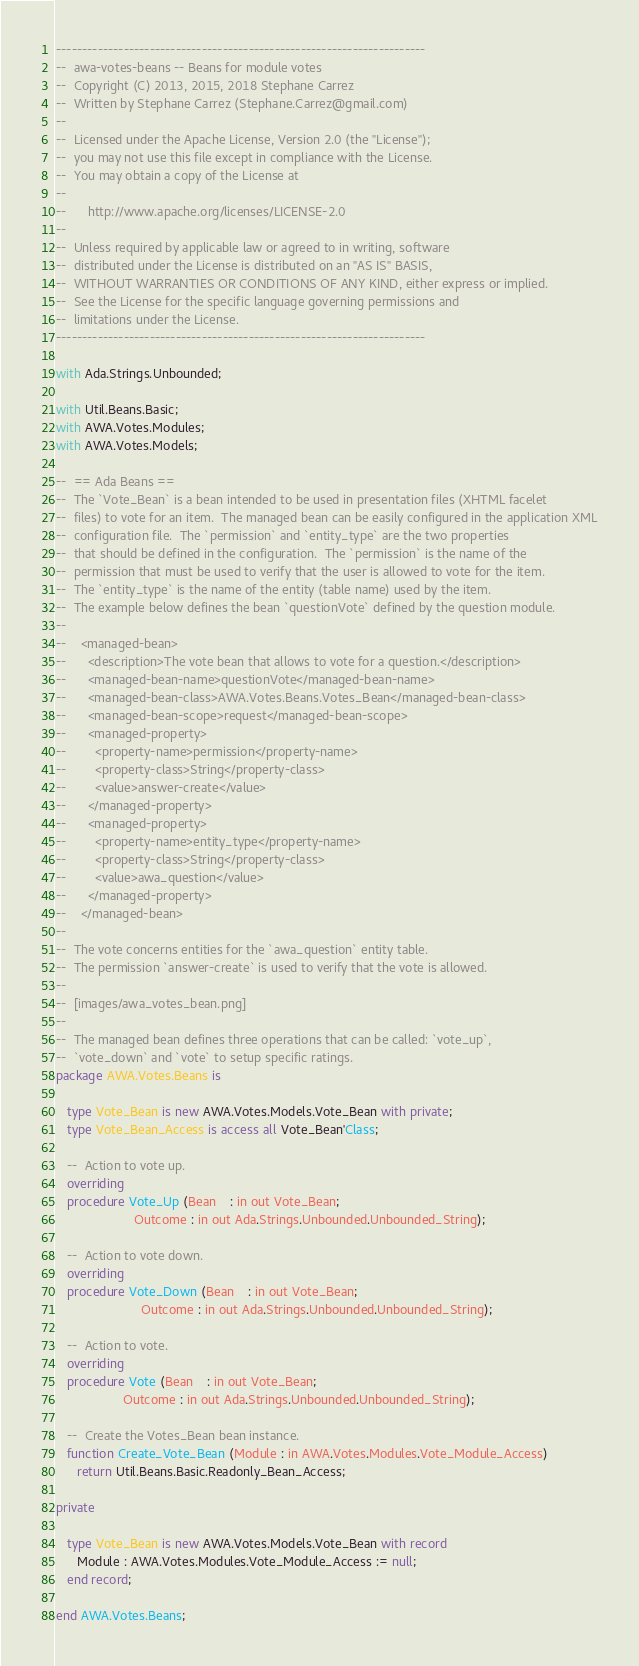<code> <loc_0><loc_0><loc_500><loc_500><_Ada_>-----------------------------------------------------------------------
--  awa-votes-beans -- Beans for module votes
--  Copyright (C) 2013, 2015, 2018 Stephane Carrez
--  Written by Stephane Carrez (Stephane.Carrez@gmail.com)
--
--  Licensed under the Apache License, Version 2.0 (the "License");
--  you may not use this file except in compliance with the License.
--  You may obtain a copy of the License at
--
--      http://www.apache.org/licenses/LICENSE-2.0
--
--  Unless required by applicable law or agreed to in writing, software
--  distributed under the License is distributed on an "AS IS" BASIS,
--  WITHOUT WARRANTIES OR CONDITIONS OF ANY KIND, either express or implied.
--  See the License for the specific language governing permissions and
--  limitations under the License.
-----------------------------------------------------------------------

with Ada.Strings.Unbounded;

with Util.Beans.Basic;
with AWA.Votes.Modules;
with AWA.Votes.Models;

--  == Ada Beans ==
--  The `Vote_Bean` is a bean intended to be used in presentation files (XHTML facelet
--  files) to vote for an item.  The managed bean can be easily configured in the application XML
--  configuration file.  The `permission` and `entity_type` are the two properties
--  that should be defined in the configuration.  The `permission` is the name of the
--  permission that must be used to verify that the user is allowed to vote for the item.
--  The `entity_type` is the name of the entity (table name) used by the item.
--  The example below defines the bean `questionVote` defined by the question module.
--
--    <managed-bean>
--      <description>The vote bean that allows to vote for a question.</description>
--      <managed-bean-name>questionVote</managed-bean-name>
--      <managed-bean-class>AWA.Votes.Beans.Votes_Bean</managed-bean-class>
--      <managed-bean-scope>request</managed-bean-scope>
--      <managed-property>
--        <property-name>permission</property-name>
--        <property-class>String</property-class>
--        <value>answer-create</value>
--      </managed-property>
--      <managed-property>
--        <property-name>entity_type</property-name>
--        <property-class>String</property-class>
--        <value>awa_question</value>
--      </managed-property>
--    </managed-bean>
--
--  The vote concerns entities for the `awa_question` entity table.
--  The permission `answer-create` is used to verify that the vote is allowed.
--
--  [images/awa_votes_bean.png]
--
--  The managed bean defines three operations that can be called: `vote_up`,
--  `vote_down` and `vote` to setup specific ratings.
package AWA.Votes.Beans is

   type Vote_Bean is new AWA.Votes.Models.Vote_Bean with private;
   type Vote_Bean_Access is access all Vote_Bean'Class;

   --  Action to vote up.
   overriding
   procedure Vote_Up (Bean    : in out Vote_Bean;
                      Outcome : in out Ada.Strings.Unbounded.Unbounded_String);

   --  Action to vote down.
   overriding
   procedure Vote_Down (Bean    : in out Vote_Bean;
                        Outcome : in out Ada.Strings.Unbounded.Unbounded_String);

   --  Action to vote.
   overriding
   procedure Vote (Bean    : in out Vote_Bean;
                   Outcome : in out Ada.Strings.Unbounded.Unbounded_String);

   --  Create the Votes_Bean bean instance.
   function Create_Vote_Bean (Module : in AWA.Votes.Modules.Vote_Module_Access)
      return Util.Beans.Basic.Readonly_Bean_Access;

private

   type Vote_Bean is new AWA.Votes.Models.Vote_Bean with record
      Module : AWA.Votes.Modules.Vote_Module_Access := null;
   end record;

end AWA.Votes.Beans;
</code> 